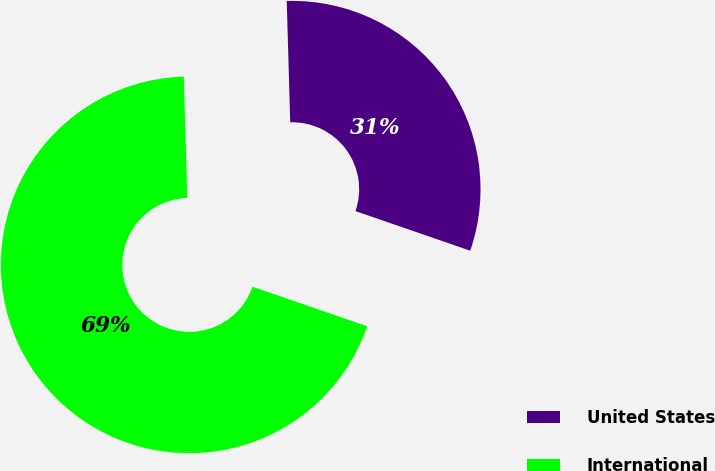Convert chart. <chart><loc_0><loc_0><loc_500><loc_500><pie_chart><fcel>United States<fcel>International<nl><fcel>30.75%<fcel>69.25%<nl></chart> 